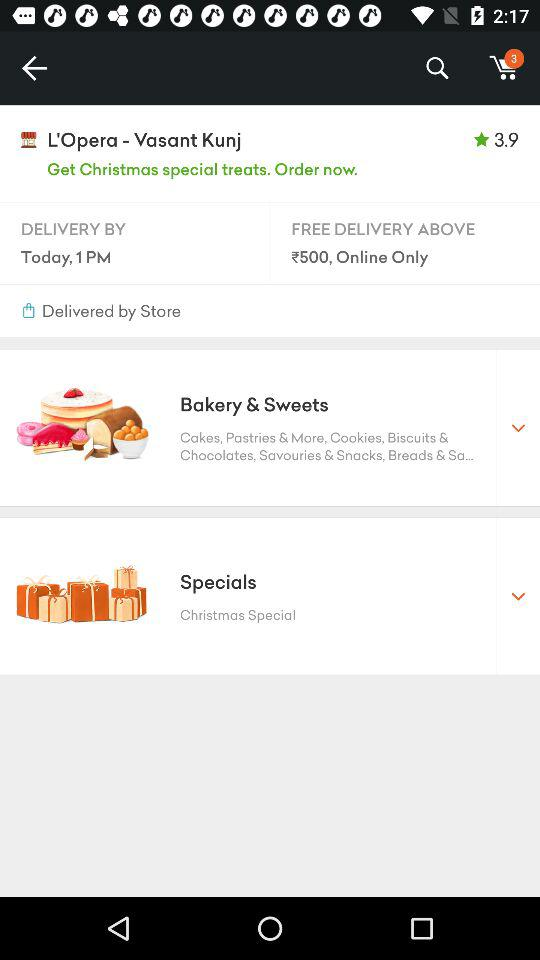At what order value is delivery free? Delivery is free for orders above ₹500. 